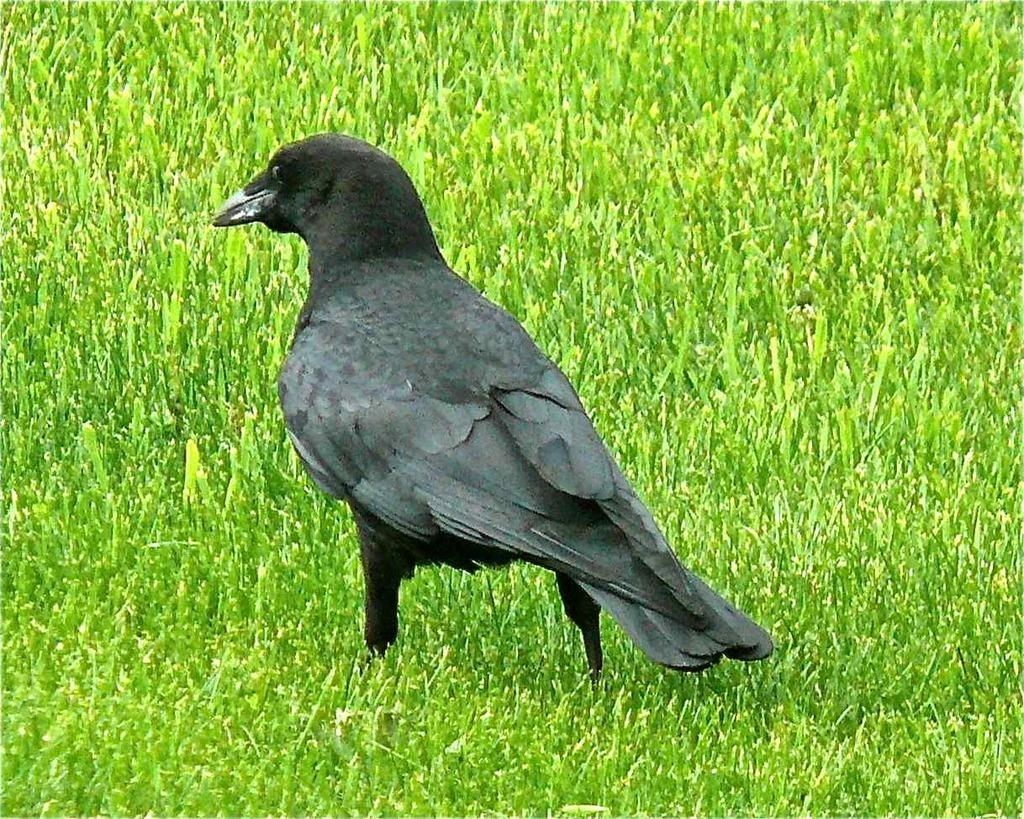What type of animal can be seen in the image? There is a bird in the image. Where is the bird located? The bird is on the grass. How many pizzas is the bird holding in the image? There are no pizzas present in the image; it features a bird on the grass. What type of expert can be seen advising the bird in the image? There is no expert present in the image; it features a bird on the grass. 